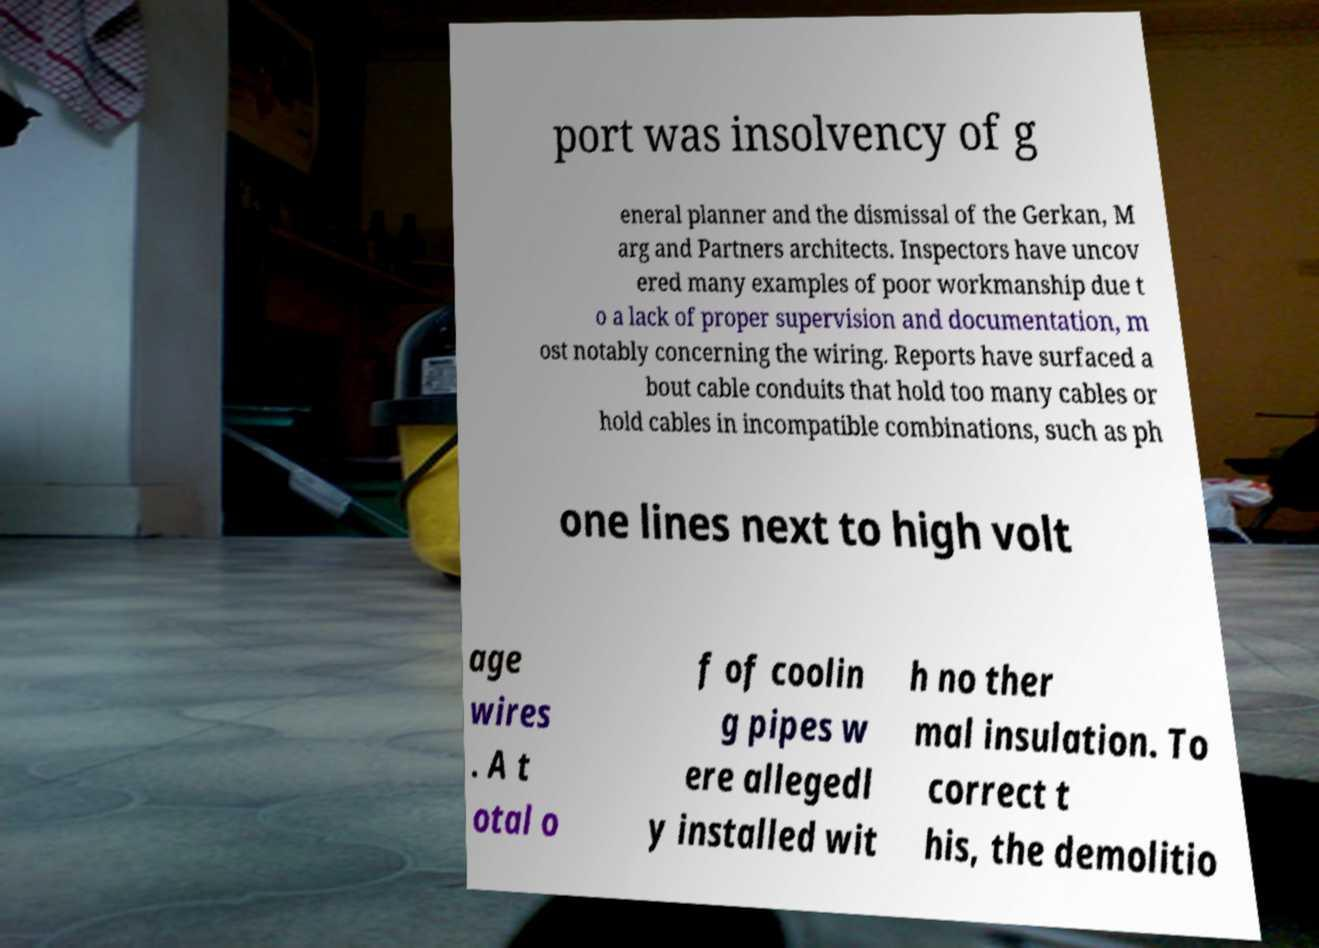For documentation purposes, I need the text within this image transcribed. Could you provide that? port was insolvency of g eneral planner and the dismissal of the Gerkan, M arg and Partners architects. Inspectors have uncov ered many examples of poor workmanship due t o a lack of proper supervision and documentation, m ost notably concerning the wiring. Reports have surfaced a bout cable conduits that hold too many cables or hold cables in incompatible combinations, such as ph one lines next to high volt age wires . A t otal o f of coolin g pipes w ere allegedl y installed wit h no ther mal insulation. To correct t his, the demolitio 